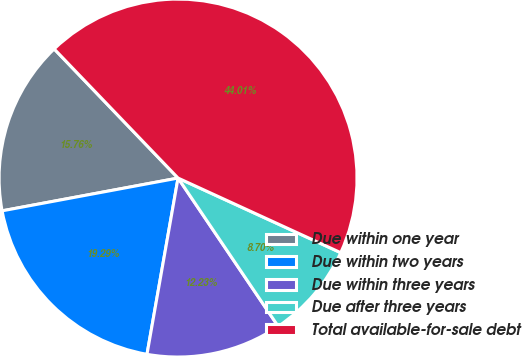<chart> <loc_0><loc_0><loc_500><loc_500><pie_chart><fcel>Due within one year<fcel>Due within two years<fcel>Due within three years<fcel>Due after three years<fcel>Total available-for-sale debt<nl><fcel>15.76%<fcel>19.29%<fcel>12.23%<fcel>8.7%<fcel>44.01%<nl></chart> 